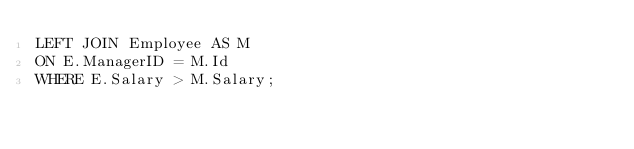Convert code to text. <code><loc_0><loc_0><loc_500><loc_500><_SQL_>LEFT JOIN Employee AS M
ON E.ManagerID = M.Id
WHERE E.Salary > M.Salary;
</code> 